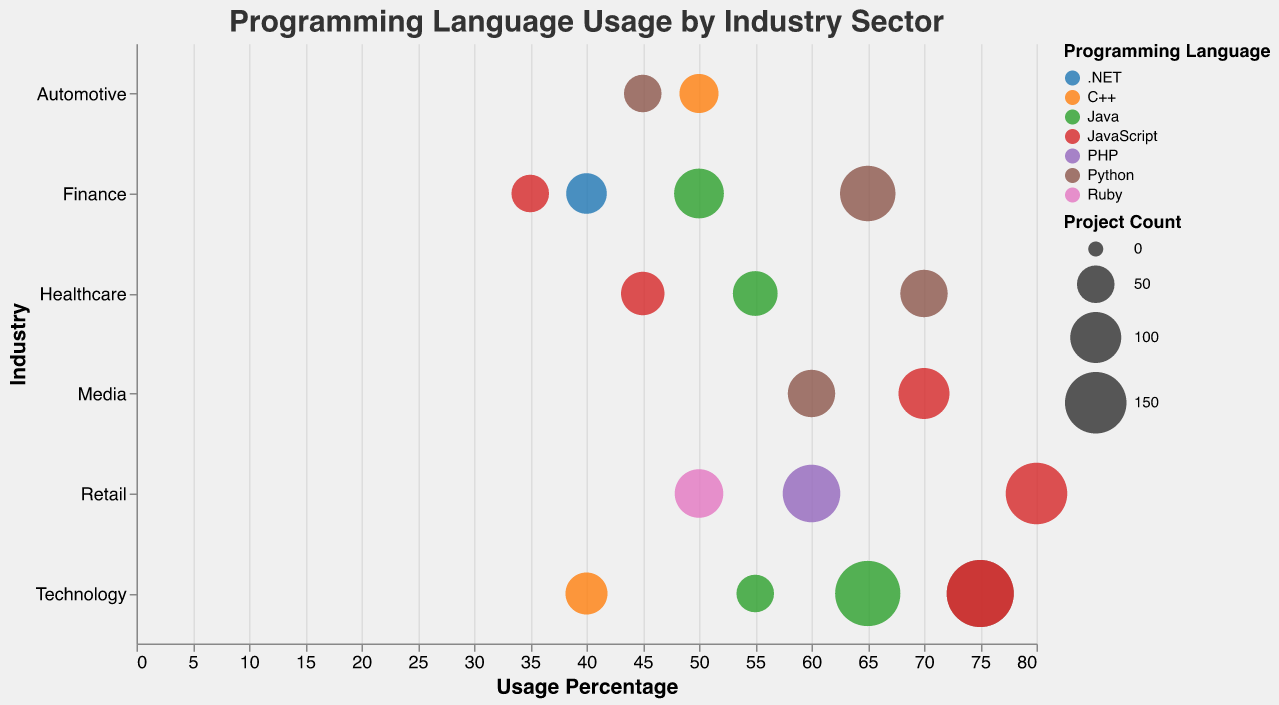What is the most commonly used programming language in the Healthcare sector? By looking at the colors representing each programming language and their corresponding coding in the Healthcare sector, Python is used with a usage percentage of 70 and counts for two sectors. Java is also used but with a lower count (one sector).
Answer: Python Which industry has the highest project count for JavaScript? The size of the circles represents the project count. For JavaScript, the largest circle is in the Retail industry with a project count of 150.
Answer: Retail Among the different sectors in the Finance industry, which programming language shows the least usage percentage? By comparing the usage percentages in the Finance industry, .NET in Insurance shows the least, with 40%.
Answer: .NET What are the Programming Languages used in the Retail industry and their respective usage percentages? The colors and corresponding keys for the Retail industry show JavaScript (80%), PHP (60%), and Ruby (50%).
Answer: JavaScript: 80%, PHP: 60%, Ruby: 50% In which sector and industry is C++ used, and what is its project count? C++ is represented by one color and can be found in the Technology (Telecommunications) and Automotive (Manufacturing) sectors. The project counts are 65 and 55, respectively.
Answer: Technology (Telecommunications) - 65, Automotive (Manufacturing) - 55 What is the average usage percentage of Python across all industries? Sum the usage percentages of Python across different industries (65+70+75+45+60) to get 315. There are five instances, so divide 315 by 5.
Answer: 63 Which industry has the highest average usage percentage across all programming languages used within it? Calculate the average usage percentage for each industry by summing the usage percentages and dividing by the number of programming languages. The Technology industry has high usage of Python (75), JavaScript (75), Java (65), and C++ (40). The averages must be compared across industries.
Answer: Technology In the Media industry, which programming language has the highest project count? Look at the size of the circles in the Media industry; JavaScript has the largest circle with a project count of 100.
Answer: JavaScript Comparing the Automotive and Media industries, which one uses Python more frequently based on usage percentage? The Automotive industry shows Python at 45%, while the Media industry shows it at 60%.
Answer: Media 